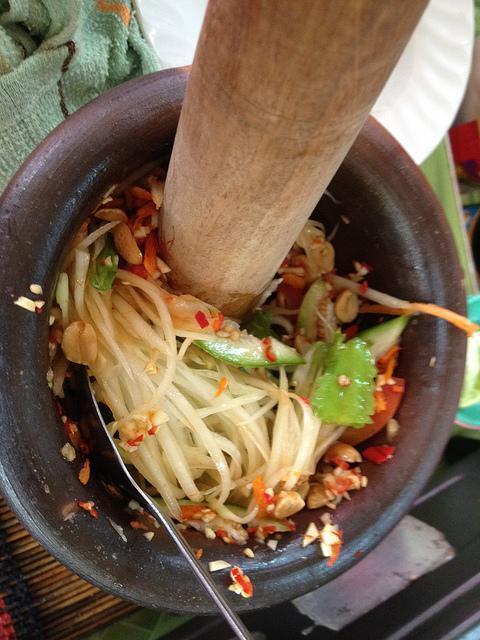What is the use of the pestle and mortar in the picture above?
Choose the right answer and clarify with the format: 'Answer: answer
Rationale: rationale.'
Options: Crash, none, smash contents, mix. Answer: smash contents.
Rationale: A pestle and mortar is used to smash ingredients. 